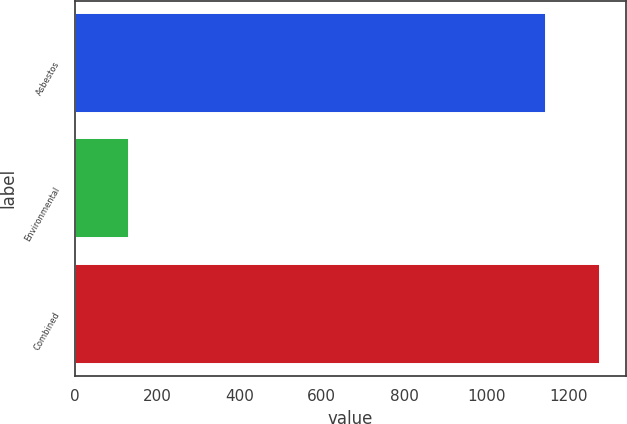Convert chart to OTSL. <chart><loc_0><loc_0><loc_500><loc_500><bar_chart><fcel>Asbestos<fcel>Environmental<fcel>Combined<nl><fcel>1145<fcel>131<fcel>1276<nl></chart> 